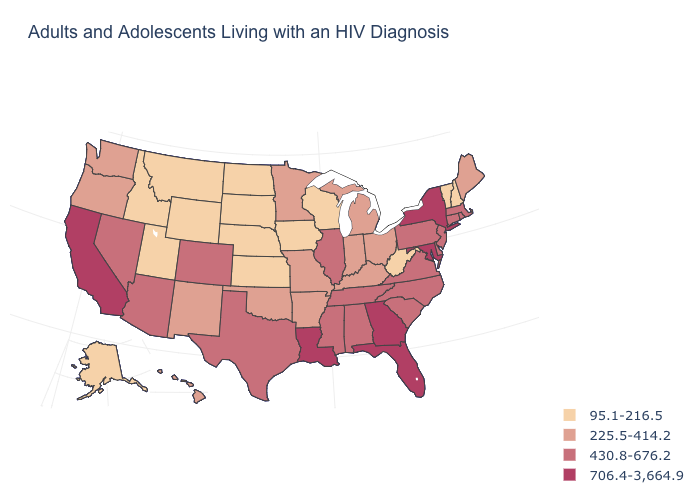Does the map have missing data?
Answer briefly. No. Is the legend a continuous bar?
Give a very brief answer. No. How many symbols are there in the legend?
Concise answer only. 4. Name the states that have a value in the range 430.8-676.2?
Give a very brief answer. Alabama, Arizona, Colorado, Connecticut, Delaware, Illinois, Massachusetts, Mississippi, Nevada, New Jersey, North Carolina, Pennsylvania, Rhode Island, South Carolina, Tennessee, Texas, Virginia. Name the states that have a value in the range 225.5-414.2?
Concise answer only. Arkansas, Hawaii, Indiana, Kentucky, Maine, Michigan, Minnesota, Missouri, New Mexico, Ohio, Oklahoma, Oregon, Washington. Name the states that have a value in the range 225.5-414.2?
Short answer required. Arkansas, Hawaii, Indiana, Kentucky, Maine, Michigan, Minnesota, Missouri, New Mexico, Ohio, Oklahoma, Oregon, Washington. What is the value of Louisiana?
Concise answer only. 706.4-3,664.9. What is the lowest value in states that border Montana?
Concise answer only. 95.1-216.5. What is the value of Connecticut?
Keep it brief. 430.8-676.2. What is the highest value in the MidWest ?
Answer briefly. 430.8-676.2. What is the value of Illinois?
Write a very short answer. 430.8-676.2. What is the highest value in the USA?
Give a very brief answer. 706.4-3,664.9. Name the states that have a value in the range 430.8-676.2?
Write a very short answer. Alabama, Arizona, Colorado, Connecticut, Delaware, Illinois, Massachusetts, Mississippi, Nevada, New Jersey, North Carolina, Pennsylvania, Rhode Island, South Carolina, Tennessee, Texas, Virginia. What is the value of Colorado?
Give a very brief answer. 430.8-676.2. 